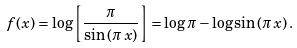Convert formula to latex. <formula><loc_0><loc_0><loc_500><loc_500>f ( x ) = \log { \left [ \frac { \pi } { \sin { ( \pi \, x ) } } \right ] } = \log { \pi } - \log { \sin { ( \pi \, x ) } } \, .</formula> 